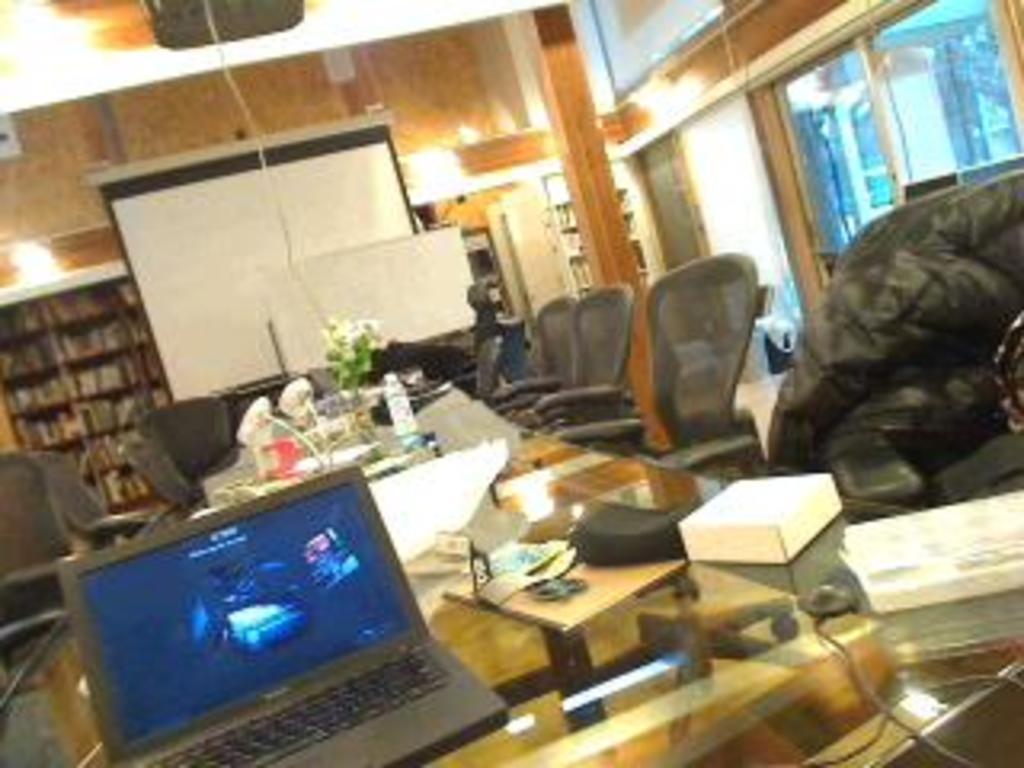Describe this image in one or two sentences. In the center we can see table on table there is a laptop,books,papers,key,bag,charm,bottles,mouse,flower vase,mug,flower. Round table we can see few empty chairs. In the background there is a wall,glass,board,shelf,books,pillar and speaker. 